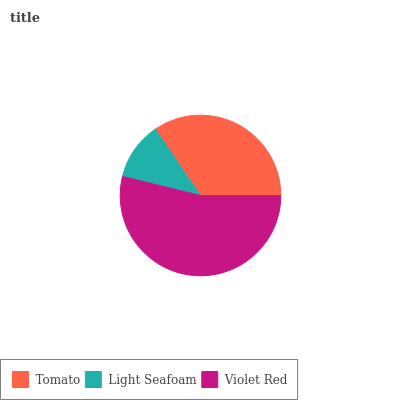Is Light Seafoam the minimum?
Answer yes or no. Yes. Is Violet Red the maximum?
Answer yes or no. Yes. Is Violet Red the minimum?
Answer yes or no. No. Is Light Seafoam the maximum?
Answer yes or no. No. Is Violet Red greater than Light Seafoam?
Answer yes or no. Yes. Is Light Seafoam less than Violet Red?
Answer yes or no. Yes. Is Light Seafoam greater than Violet Red?
Answer yes or no. No. Is Violet Red less than Light Seafoam?
Answer yes or no. No. Is Tomato the high median?
Answer yes or no. Yes. Is Tomato the low median?
Answer yes or no. Yes. Is Light Seafoam the high median?
Answer yes or no. No. Is Violet Red the low median?
Answer yes or no. No. 